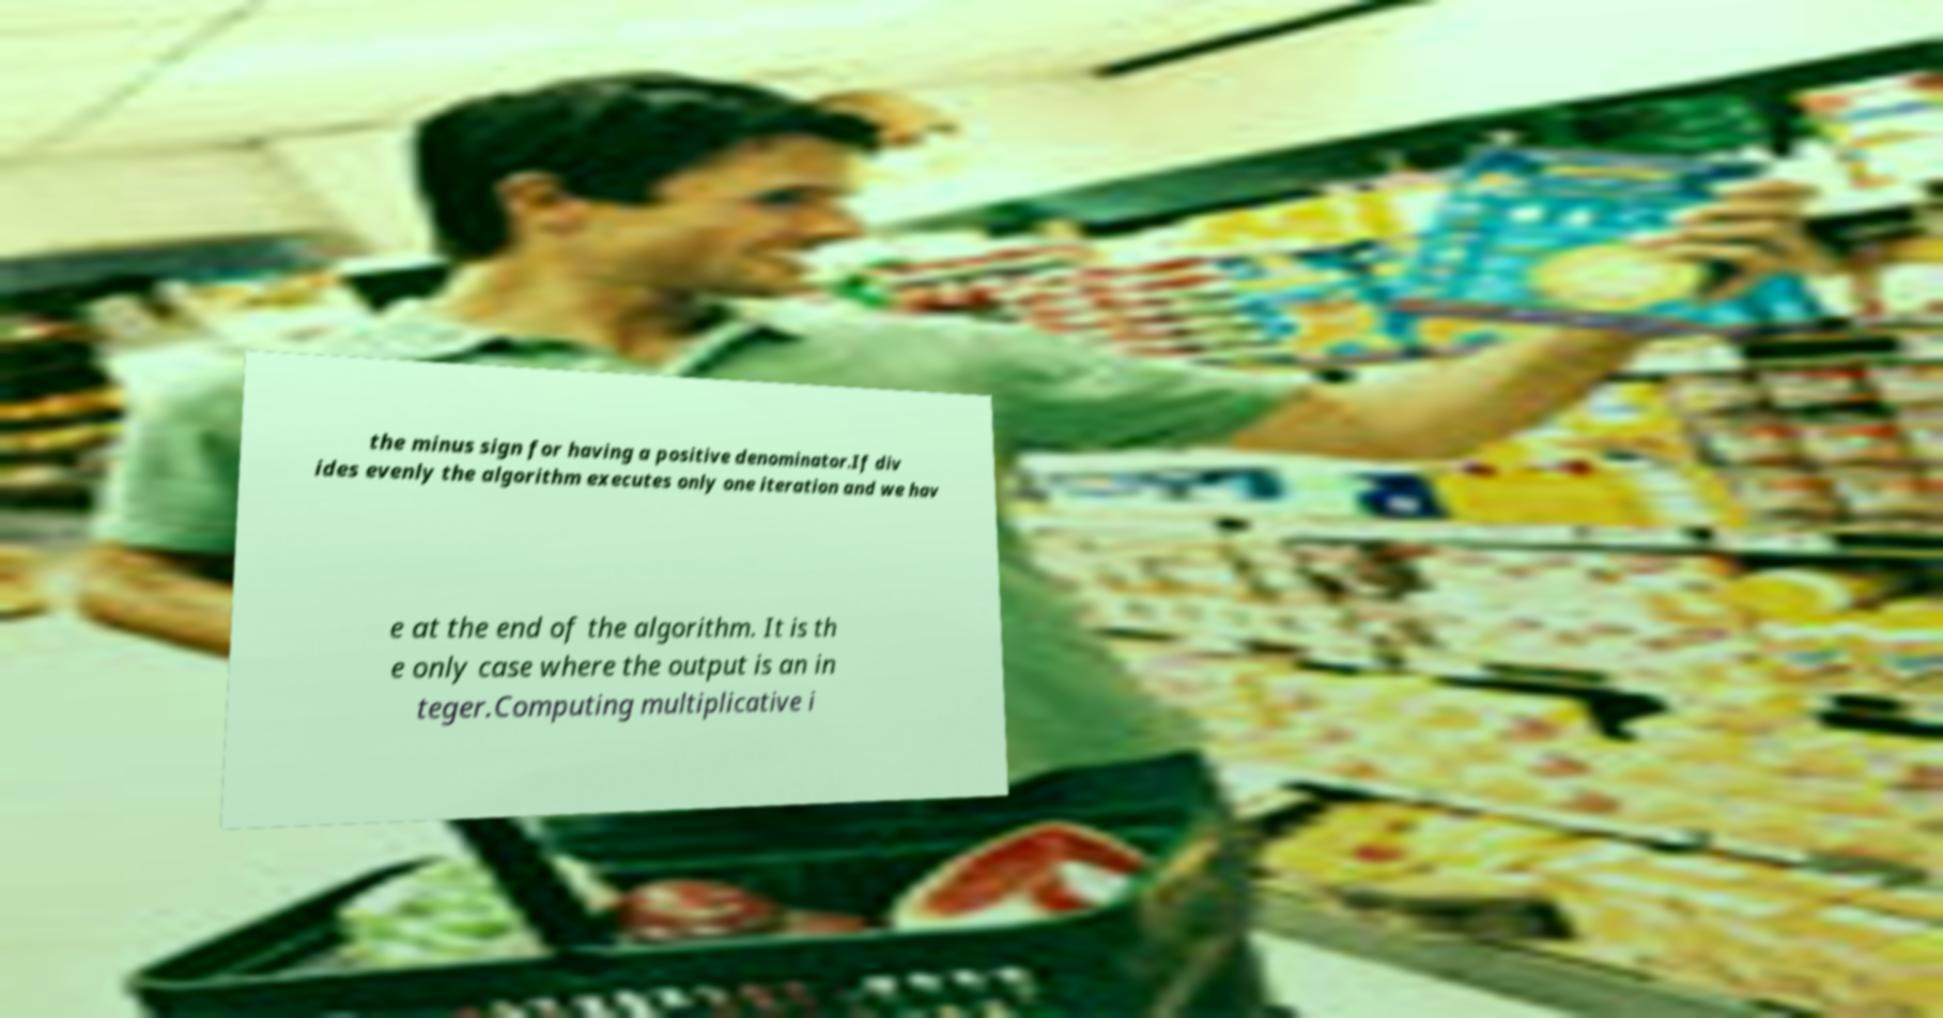For documentation purposes, I need the text within this image transcribed. Could you provide that? the minus sign for having a positive denominator.If div ides evenly the algorithm executes only one iteration and we hav e at the end of the algorithm. It is th e only case where the output is an in teger.Computing multiplicative i 